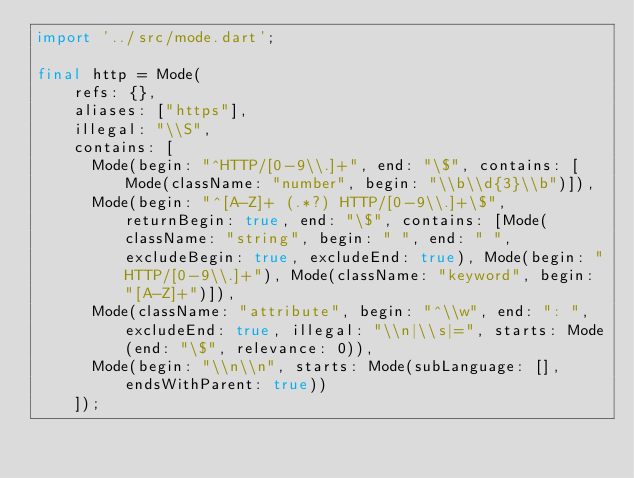Convert code to text. <code><loc_0><loc_0><loc_500><loc_500><_Dart_>import '../src/mode.dart';

final http = Mode(
    refs: {},
    aliases: ["https"],
    illegal: "\\S",
    contains: [
      Mode(begin: "^HTTP/[0-9\\.]+", end: "\$", contains: [Mode(className: "number", begin: "\\b\\d{3}\\b")]),
      Mode(begin: "^[A-Z]+ (.*?) HTTP/[0-9\\.]+\$", returnBegin: true, end: "\$", contains: [Mode(className: "string", begin: " ", end: " ", excludeBegin: true, excludeEnd: true), Mode(begin: "HTTP/[0-9\\.]+"), Mode(className: "keyword", begin: "[A-Z]+")]),
      Mode(className: "attribute", begin: "^\\w", end: ": ", excludeEnd: true, illegal: "\\n|\\s|=", starts: Mode(end: "\$", relevance: 0)),
      Mode(begin: "\\n\\n", starts: Mode(subLanguage: [], endsWithParent: true))
    ]);
</code> 